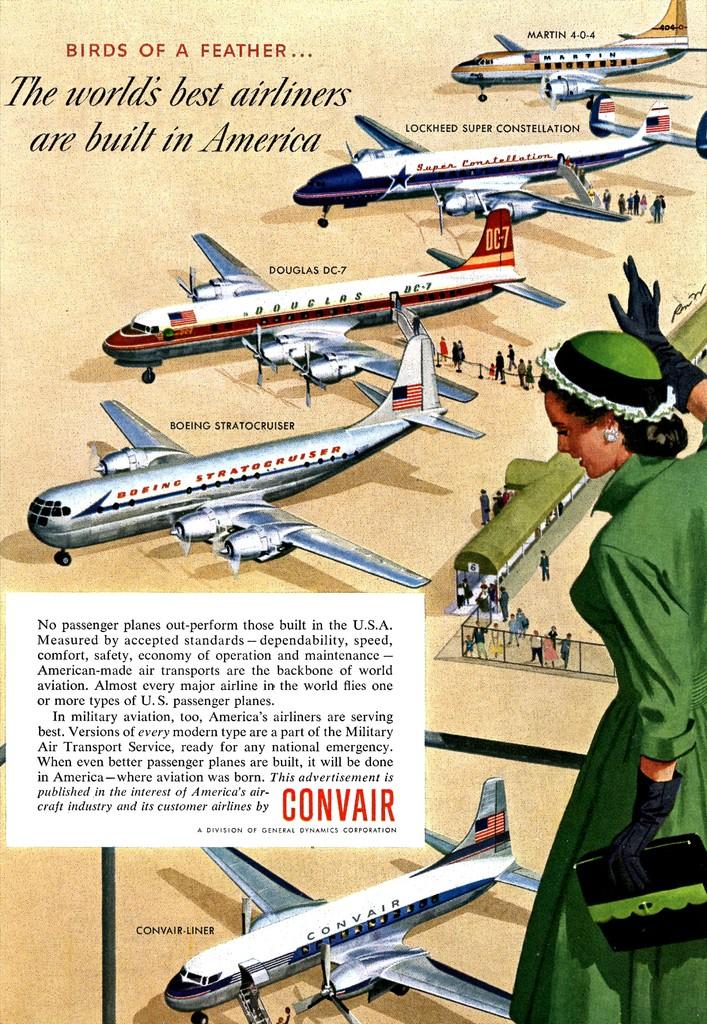How many planes in the picture?
Your answer should be very brief. 5. 